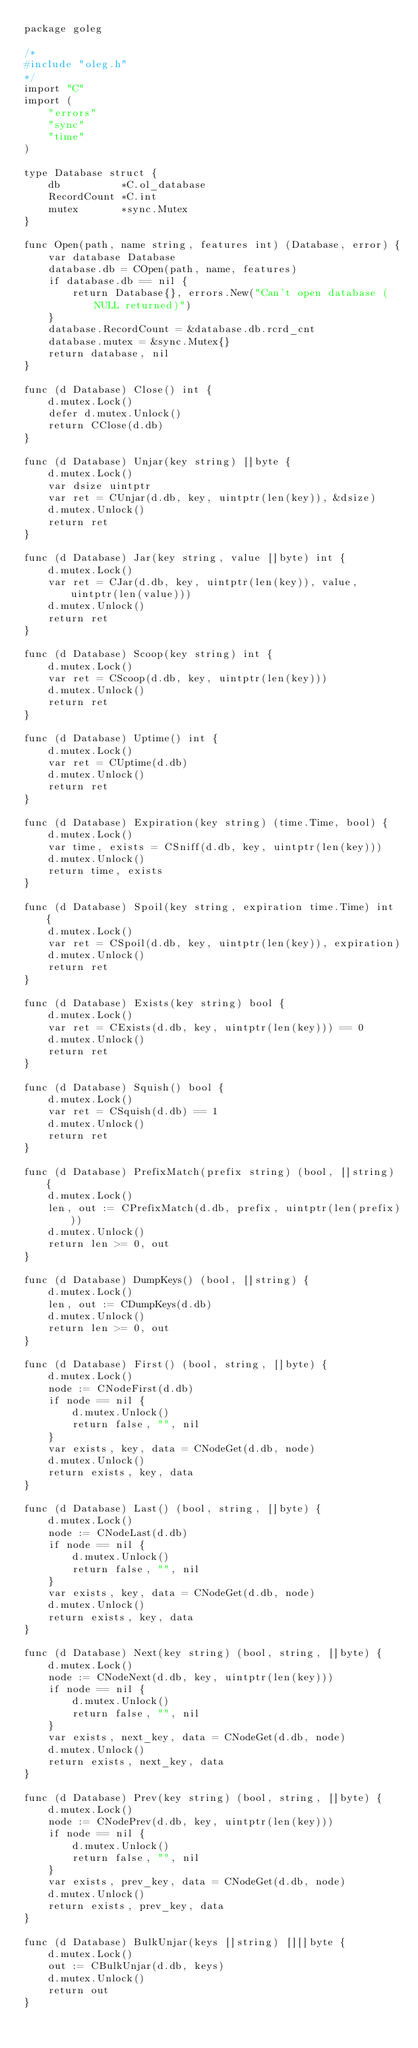Convert code to text. <code><loc_0><loc_0><loc_500><loc_500><_Go_>package goleg

/*
#include "oleg.h"
*/
import "C"
import (
	"errors"
	"sync"
	"time"
)

type Database struct {
	db          *C.ol_database
	RecordCount *C.int
	mutex       *sync.Mutex
}

func Open(path, name string, features int) (Database, error) {
	var database Database
	database.db = COpen(path, name, features)
	if database.db == nil {
		return Database{}, errors.New("Can't open database (NULL returned)")
	}
	database.RecordCount = &database.db.rcrd_cnt
	database.mutex = &sync.Mutex{}
	return database, nil
}

func (d Database) Close() int {
	d.mutex.Lock()
	defer d.mutex.Unlock()
	return CClose(d.db)
}

func (d Database) Unjar(key string) []byte {
	d.mutex.Lock()
	var dsize uintptr
	var ret = CUnjar(d.db, key, uintptr(len(key)), &dsize)
	d.mutex.Unlock()
	return ret
}

func (d Database) Jar(key string, value []byte) int {
	d.mutex.Lock()
	var ret = CJar(d.db, key, uintptr(len(key)), value, uintptr(len(value)))
	d.mutex.Unlock()
	return ret
}

func (d Database) Scoop(key string) int {
	d.mutex.Lock()
	var ret = CScoop(d.db, key, uintptr(len(key)))
	d.mutex.Unlock()
	return ret
}

func (d Database) Uptime() int {
	d.mutex.Lock()
	var ret = CUptime(d.db)
	d.mutex.Unlock()
	return ret
}

func (d Database) Expiration(key string) (time.Time, bool) {
	d.mutex.Lock()
	var time, exists = CSniff(d.db, key, uintptr(len(key)))
	d.mutex.Unlock()
	return time, exists
}

func (d Database) Spoil(key string, expiration time.Time) int {
	d.mutex.Lock()
	var ret = CSpoil(d.db, key, uintptr(len(key)), expiration)
	d.mutex.Unlock()
	return ret
}

func (d Database) Exists(key string) bool {
	d.mutex.Lock()
	var ret = CExists(d.db, key, uintptr(len(key))) == 0
	d.mutex.Unlock()
	return ret
}

func (d Database) Squish() bool {
	d.mutex.Lock()
	var ret = CSquish(d.db) == 1
	d.mutex.Unlock()
	return ret
}

func (d Database) PrefixMatch(prefix string) (bool, []string) {
	d.mutex.Lock()
	len, out := CPrefixMatch(d.db, prefix, uintptr(len(prefix)))
	d.mutex.Unlock()
	return len >= 0, out
}

func (d Database) DumpKeys() (bool, []string) {
	d.mutex.Lock()
	len, out := CDumpKeys(d.db)
	d.mutex.Unlock()
	return len >= 0, out
}

func (d Database) First() (bool, string, []byte) {
	d.mutex.Lock()
	node := CNodeFirst(d.db)
	if node == nil {
		d.mutex.Unlock()
		return false, "", nil
	}
	var exists, key, data = CNodeGet(d.db, node)
	d.mutex.Unlock()
	return exists, key, data
}

func (d Database) Last() (bool, string, []byte) {
	d.mutex.Lock()
	node := CNodeLast(d.db)
	if node == nil {
		d.mutex.Unlock()
		return false, "", nil
	}
	var exists, key, data = CNodeGet(d.db, node)
	d.mutex.Unlock()
	return exists, key, data
}

func (d Database) Next(key string) (bool, string, []byte) {
	d.mutex.Lock()
	node := CNodeNext(d.db, key, uintptr(len(key)))
	if node == nil {
		d.mutex.Unlock()
		return false, "", nil
	}
	var exists, next_key, data = CNodeGet(d.db, node)
	d.mutex.Unlock()
	return exists, next_key, data
}

func (d Database) Prev(key string) (bool, string, []byte) {
	d.mutex.Lock()
	node := CNodePrev(d.db, key, uintptr(len(key)))
	if node == nil {
		d.mutex.Unlock()
		return false, "", nil
	}
	var exists, prev_key, data = CNodeGet(d.db, node)
	d.mutex.Unlock()
	return exists, prev_key, data
}

func (d Database) BulkUnjar(keys []string) [][]byte {
	d.mutex.Lock()
	out := CBulkUnjar(d.db, keys)
	d.mutex.Unlock()
	return out
}
</code> 